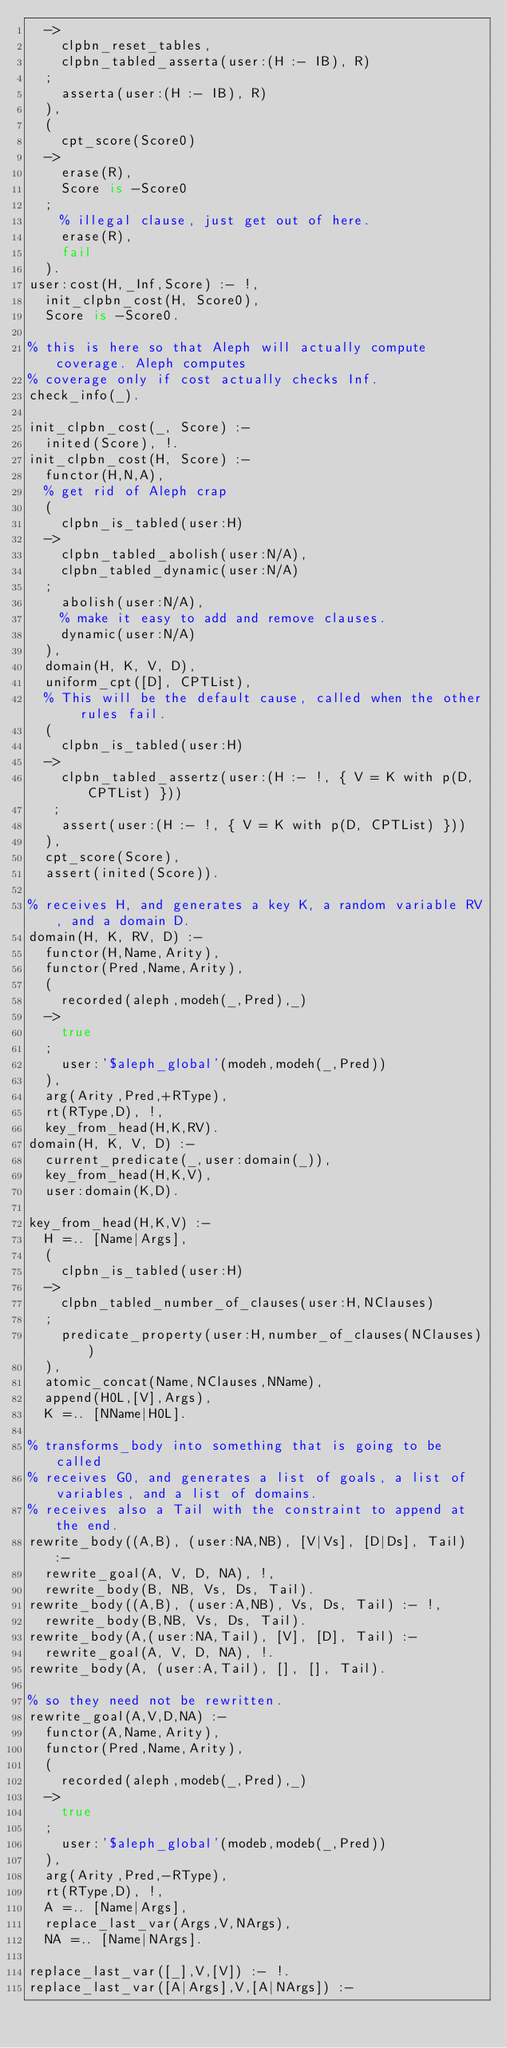Convert code to text. <code><loc_0><loc_0><loc_500><loc_500><_Prolog_>	->
	  clpbn_reset_tables,
	  clpbn_tabled_asserta(user:(H :- IB), R)
	;
	  asserta(user:(H :- IB), R)
	),
	(
	  cpt_score(Score0)
	->
	  erase(R),
	  Score is -Score0
	;
	  % illegal clause, just get out of here.
	  erase(R),
	  fail
	).
user:cost(H,_Inf,Score) :- !,
	init_clpbn_cost(H, Score0),
	Score is -Score0.

% this is here so that Aleph will actually compute coverage. Aleph computes
% coverage only if cost actually checks Inf.
check_info(_).

init_clpbn_cost(_, Score) :-
	inited(Score), !.
init_clpbn_cost(H, Score) :-
	functor(H,N,A),
	% get rid of Aleph crap
	(
	  clpbn_is_tabled(user:H)
	->
	  clpbn_tabled_abolish(user:N/A),
	  clpbn_tabled_dynamic(user:N/A)
	;
	  abolish(user:N/A),
	  % make it easy to add and remove clauses.
	  dynamic(user:N/A)
	),
	domain(H, K, V, D),
	uniform_cpt([D], CPTList),
	% This will be the default cause, called when the other rules fail.
	(
	  clpbn_is_tabled(user:H)
	->
	  clpbn_tabled_assertz(user:(H :- !, { V = K with p(D, CPTList) }))
	 ;
	  assert(user:(H :- !, { V = K with p(D, CPTList) }))
	),
	cpt_score(Score),
	assert(inited(Score)).

% receives H, and generates a key K, a random variable RV, and a domain D.
domain(H, K, RV, D) :-
	functor(H,Name,Arity),
	functor(Pred,Name,Arity),
	(
	  recorded(aleph,modeh(_,Pred),_)
	->
	  true
	;
	  user:'$aleph_global'(modeh,modeh(_,Pred))
	),
	arg(Arity,Pred,+RType),
	rt(RType,D), !,
	key_from_head(H,K,RV).
domain(H, K, V, D) :-
	current_predicate(_,user:domain(_)),
	key_from_head(H,K,V),
	user:domain(K,D).

key_from_head(H,K,V) :-
	H =.. [Name|Args],
	(
	  clpbn_is_tabled(user:H)
	->
	  clpbn_tabled_number_of_clauses(user:H,NClauses)
	;
	  predicate_property(user:H,number_of_clauses(NClauses))
	),
	atomic_concat(Name,NClauses,NName),
	append(H0L,[V],Args),
	K =.. [NName|H0L].

% transforms_body into something that is going to be called
% receives G0, and generates a list of goals, a list of variables, and a list of domains.
% receives also a Tail with the constraint to append at the end.
rewrite_body((A,B), (user:NA,NB), [V|Vs], [D|Ds], Tail) :-
	rewrite_goal(A, V, D, NA), !,
	rewrite_body(B, NB, Vs, Ds, Tail).
rewrite_body((A,B), (user:A,NB), Vs, Ds, Tail) :- !,
	rewrite_body(B,NB, Vs, Ds, Tail).
rewrite_body(A,(user:NA,Tail), [V], [D], Tail) :-
	rewrite_goal(A, V, D, NA), !.
rewrite_body(A, (user:A,Tail), [], [], Tail).

% so they need not be rewritten.
rewrite_goal(A,V,D,NA) :-
	functor(A,Name,Arity),
	functor(Pred,Name,Arity),
	(
	  recorded(aleph,modeb(_,Pred),_)
	->
	  true
	;
	  user:'$aleph_global'(modeb,modeb(_,Pred))
	),
	arg(Arity,Pred,-RType),
	rt(RType,D), !,
	A =.. [Name|Args],
	replace_last_var(Args,V,NArgs),
	NA =.. [Name|NArgs].

replace_last_var([_],V,[V]) :- !.
replace_last_var([A|Args],V,[A|NArgs]) :-</code> 